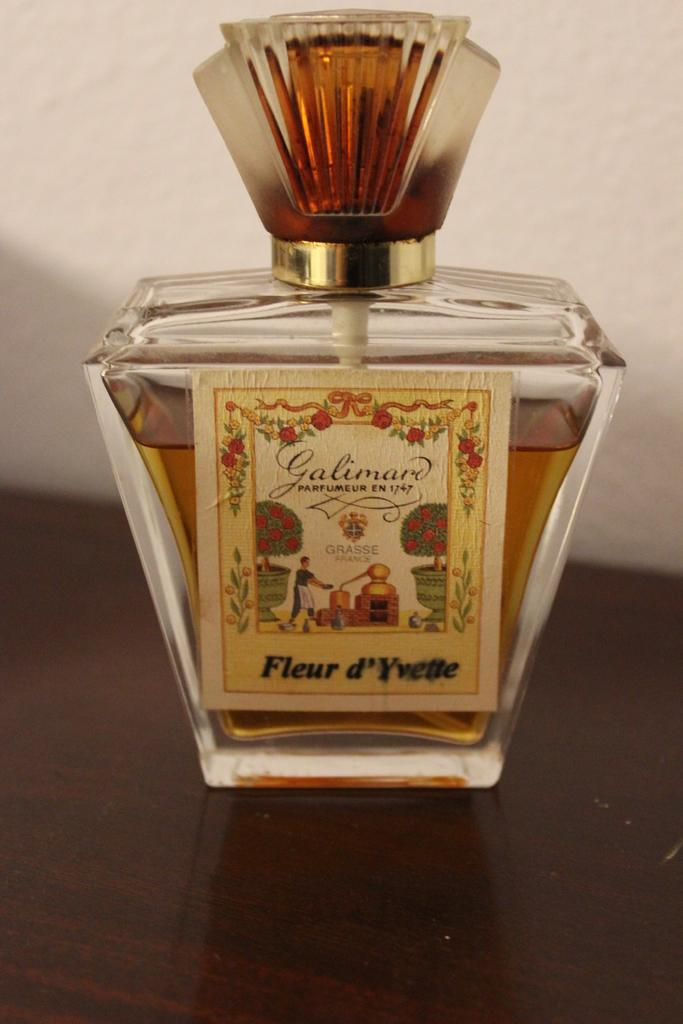<image>
Write a terse but informative summary of the picture. A yellow bottle of liquid containing fleur d'yvette. 